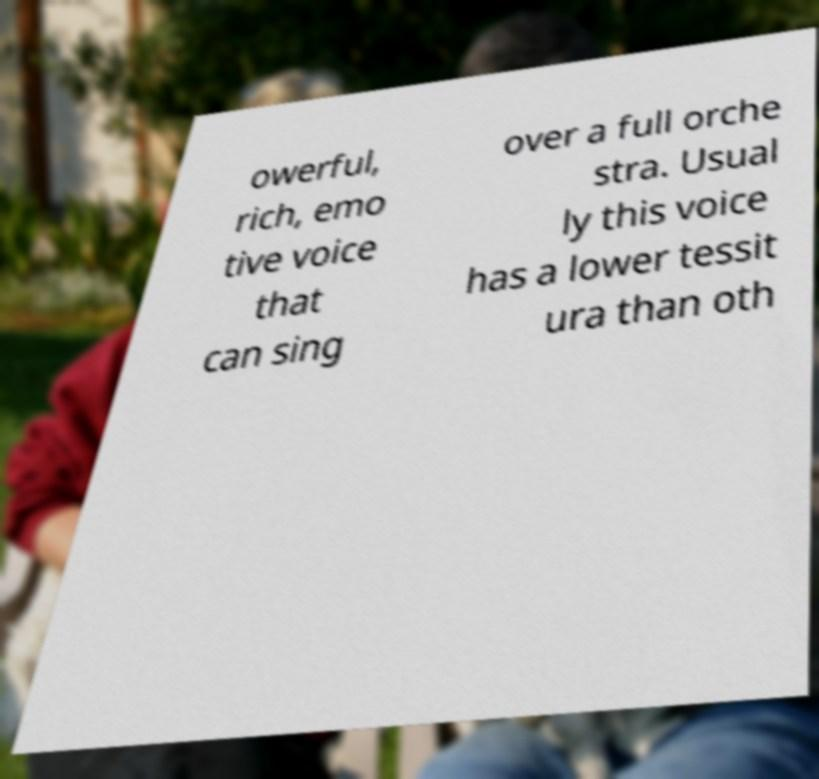Can you accurately transcribe the text from the provided image for me? owerful, rich, emo tive voice that can sing over a full orche stra. Usual ly this voice has a lower tessit ura than oth 